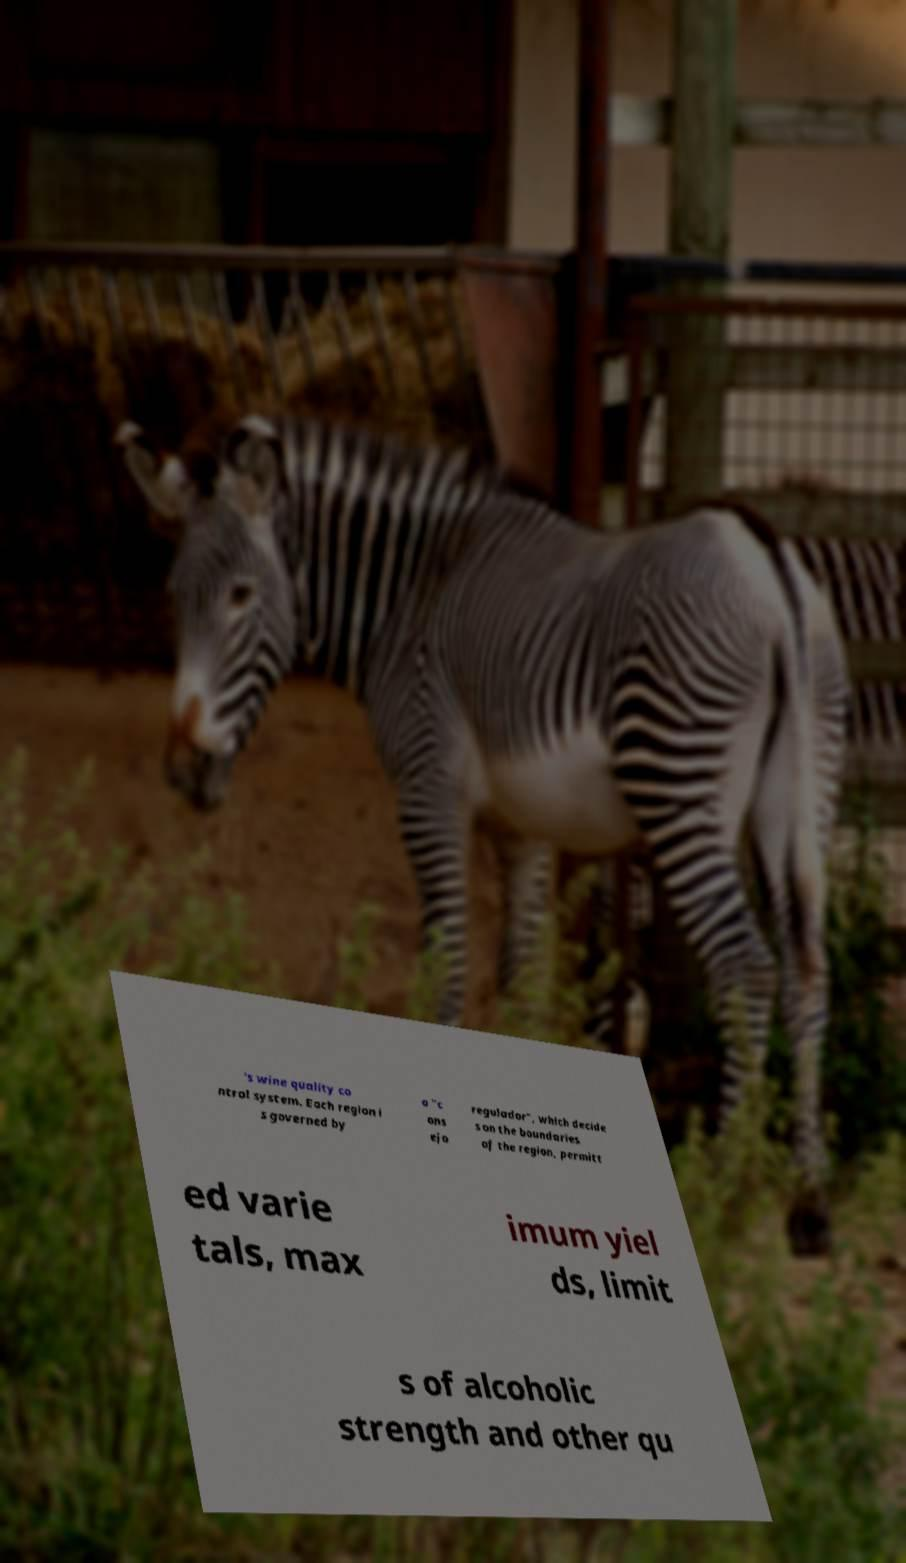For documentation purposes, I need the text within this image transcribed. Could you provide that? 's wine quality co ntrol system. Each region i s governed by a "c ons ejo regulador", which decide s on the boundaries of the region, permitt ed varie tals, max imum yiel ds, limit s of alcoholic strength and other qu 